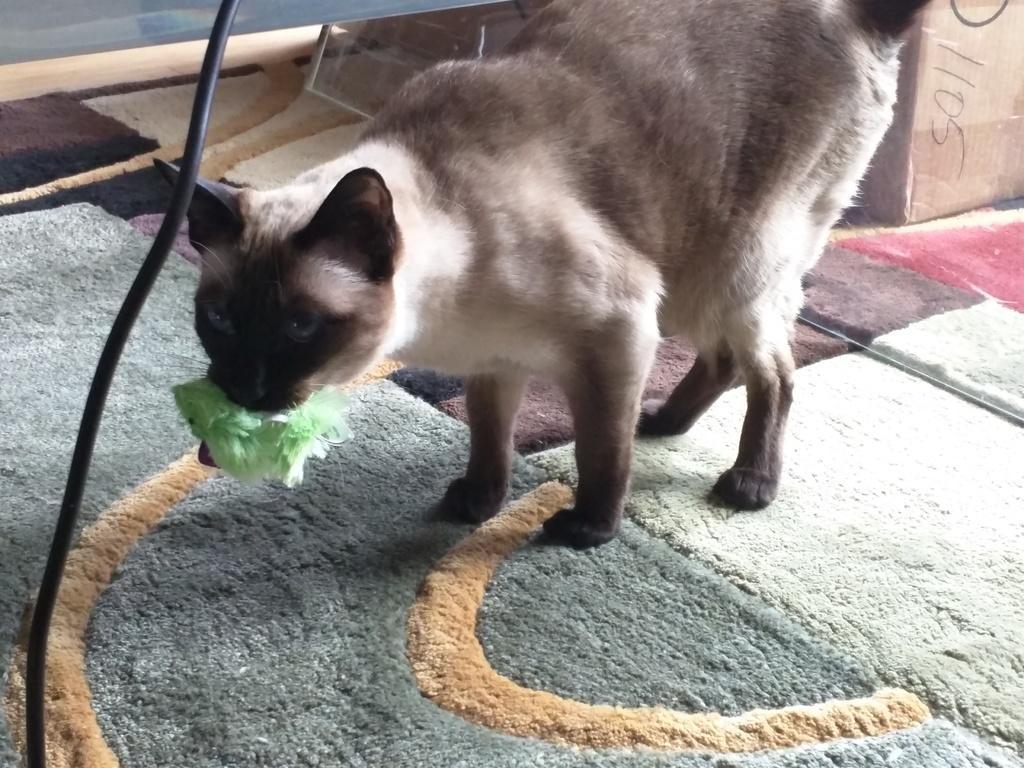Could you give a brief overview of what you see in this image? There is a cat on the carpet. Cat is holding something in the mouth. There is a wire. In the right top corner there is a box. 